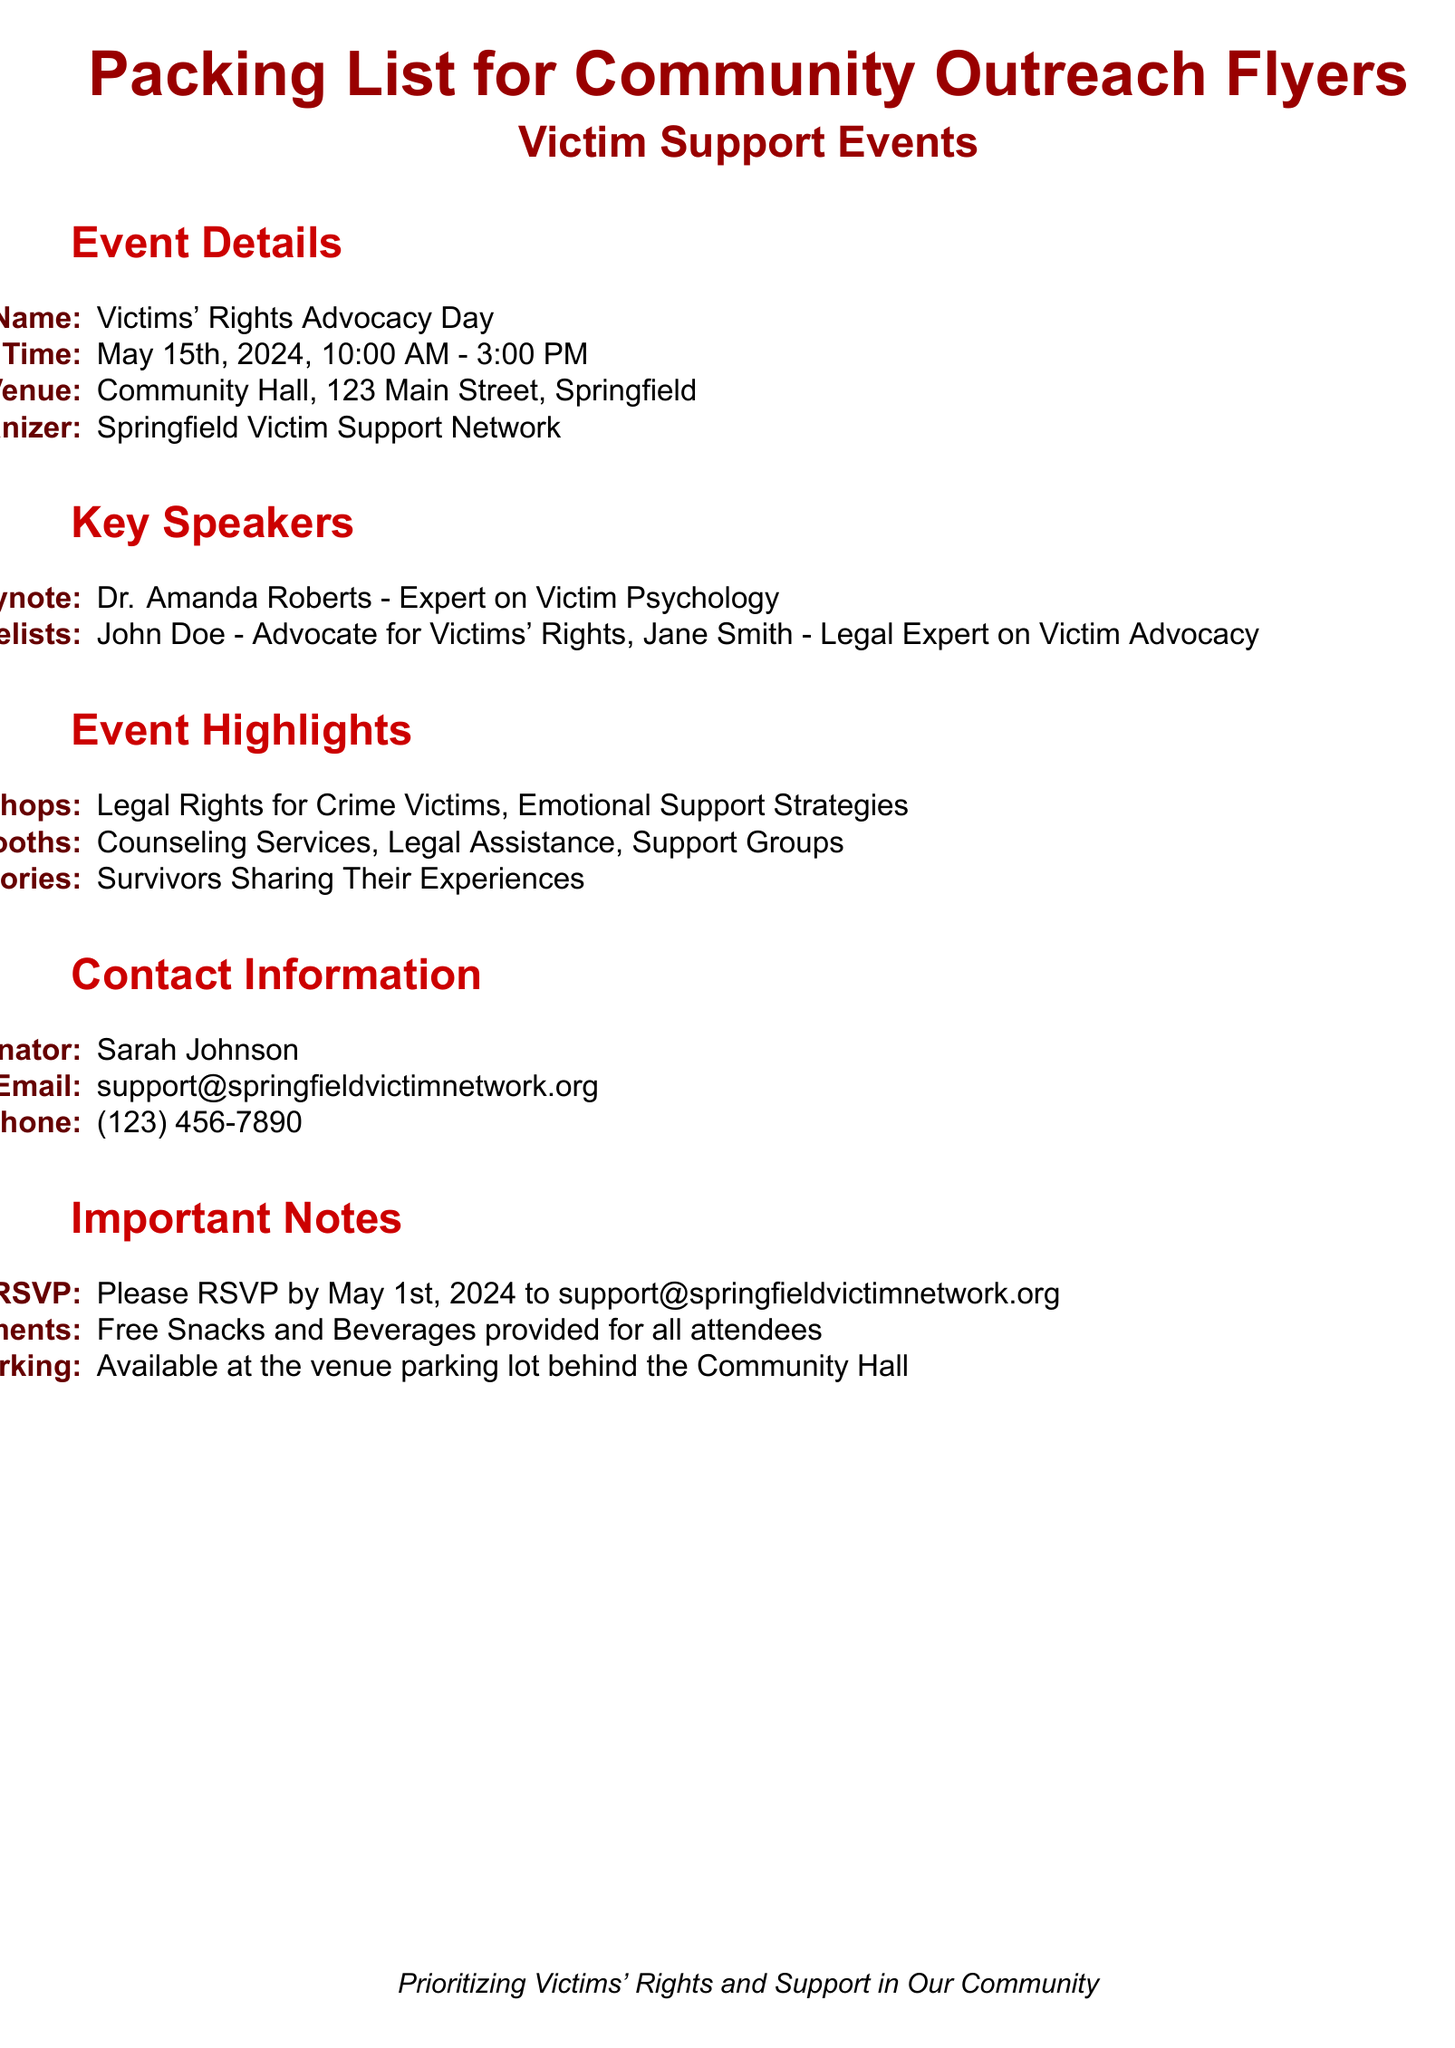What is the event name? The event name is listed in the document under the event details section.
Answer: Victims' Rights Advocacy Day What is the date of the event? The date is provided in the event details section.
Answer: May 15th, 2024 Who is the keynote speaker? The keynote speaker can be found in the key speakers section of the document.
Answer: Dr. Amanda Roberts What are the two types of workshops mentioned? The types of workshops are specified in the event highlights section.
Answer: Legal Rights for Crime Victims, Emotional Support Strategies What is the RSVP deadline? The RSVP deadline is indicated in the important notes section.
Answer: May 1st, 2024 How many resource booths are mentioned? The number of resource booths is determined by the items listed in the event highlights section.
Answer: Three Who is the event coordinator? The name of the event coordinator is provided in the contact information section.
Answer: Sarah Johnson What is the phone number for the event coordinator? The phone number can be found in the contact information section of the document.
Answer: (123) 456-7890 What refreshments are provided? The type of refreshments provided is stated in the important notes section.
Answer: Free Snacks and Beverages 